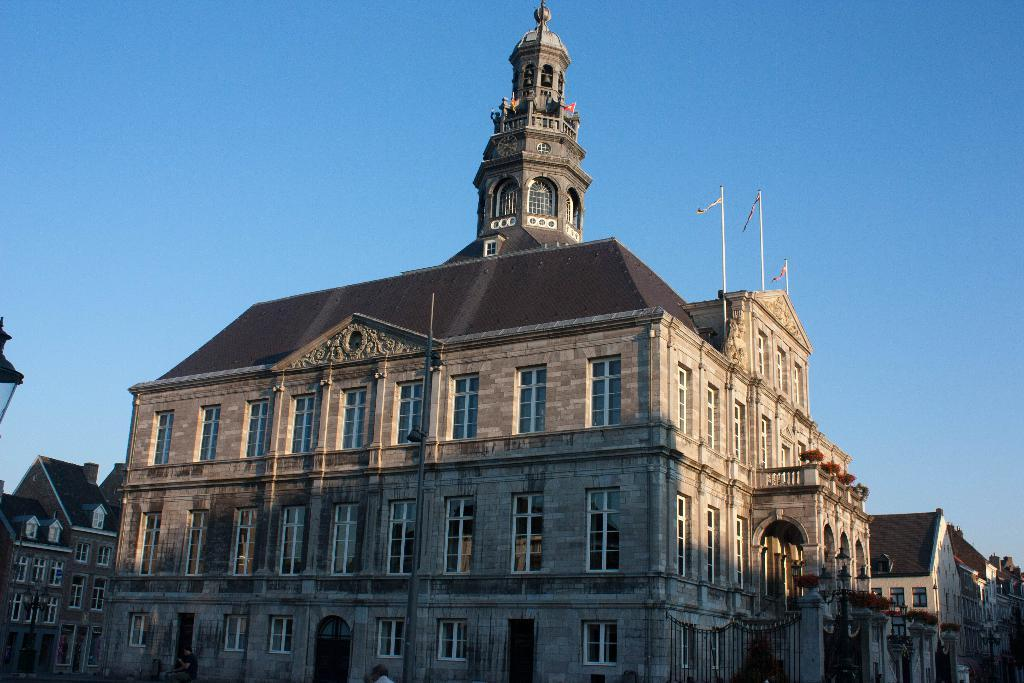What type of structures can be seen in the image? There are buildings in the image. What feature is visible on the buildings? There are windows visible in the image. What else can be seen on the buildings? There are flagpoles in the image. What is happening on the road in the image? There is a group of people on the road in the image. What part of the natural environment is visible in the image? The sky is visible in the image. Based on the visibility of the sky and the presence of people, can we determine the time of day the image was taken? The image was likely taken during the day. How does the image adjust the volume of the quiet environment? The image does not adjust the volume of any environment, as it is a static representation and not an interactive device. 